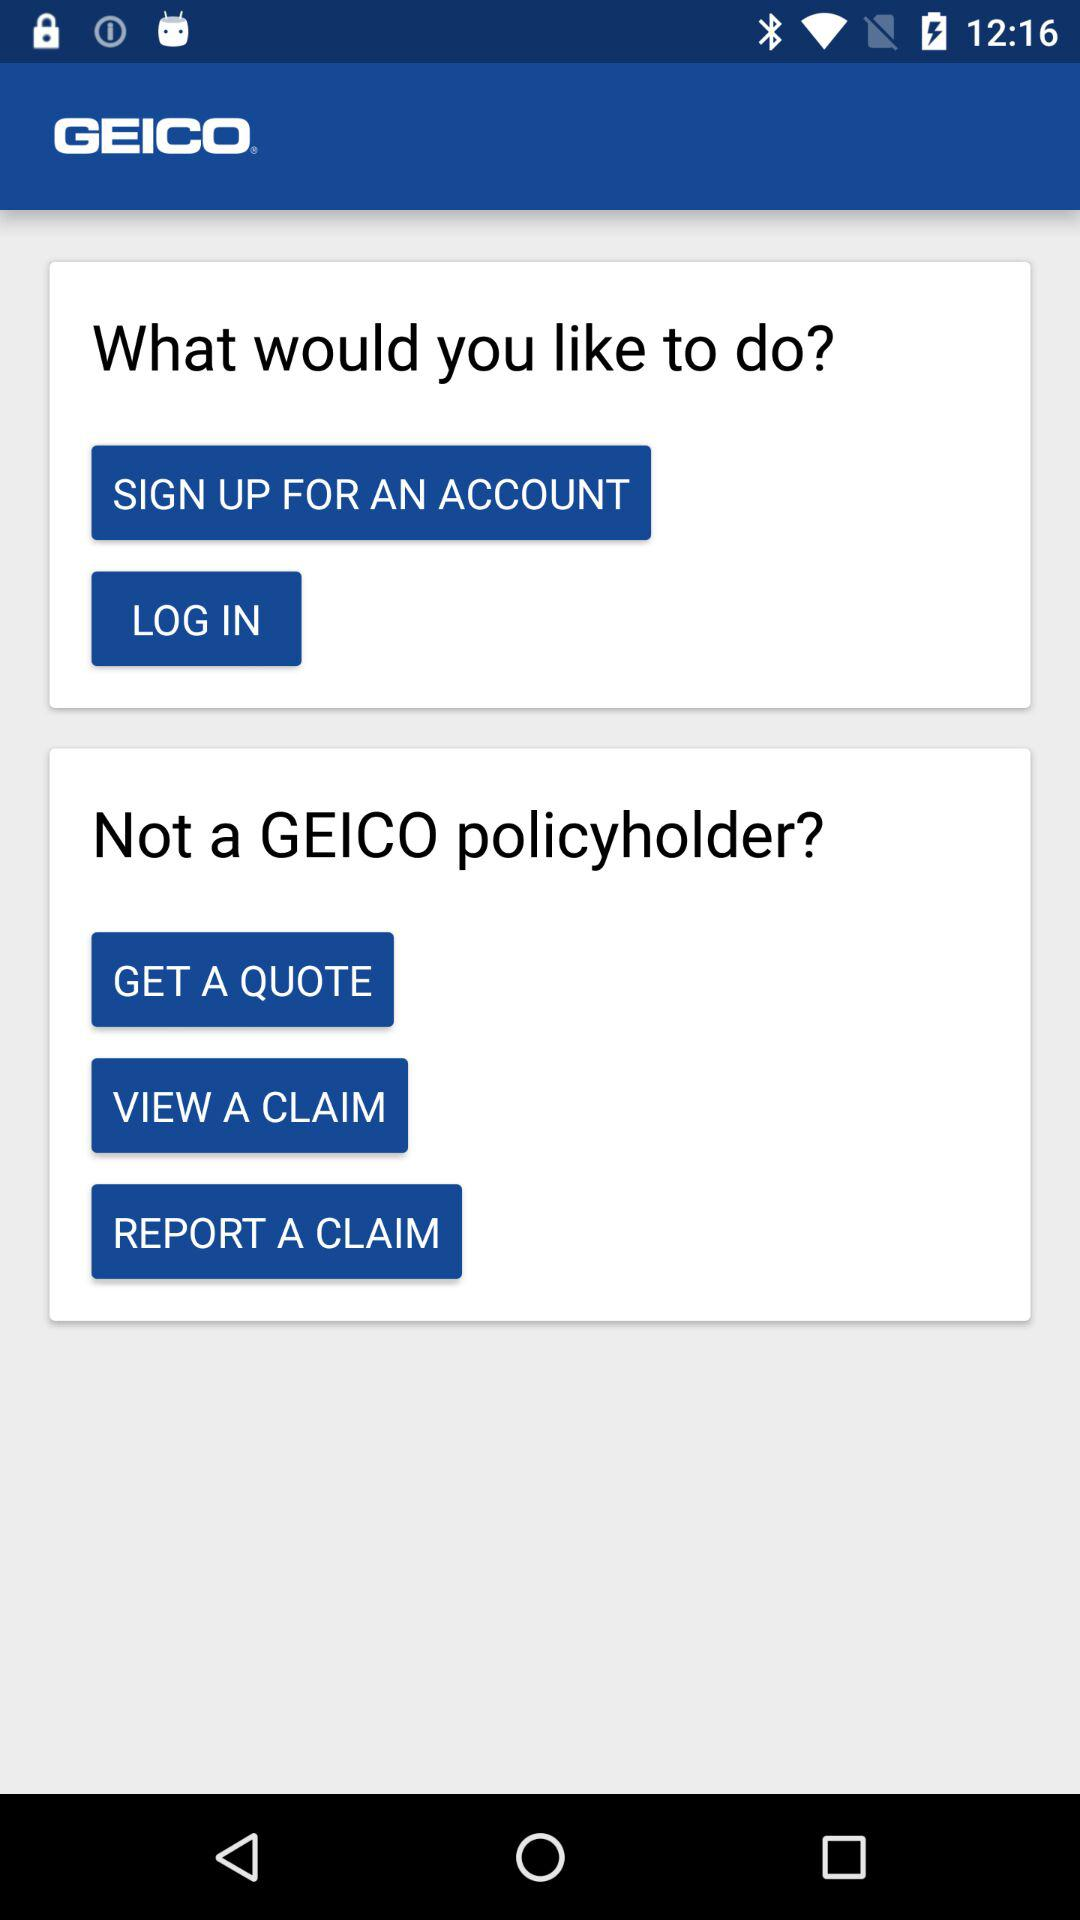How much is the insurance quote?
When the provided information is insufficient, respond with <no answer>. <no answer> 